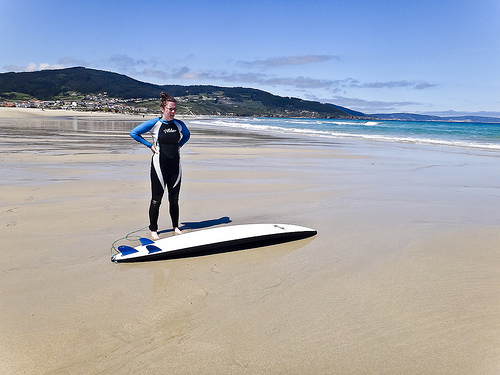Please provide a short description for this region: [0.24, 0.3, 0.41, 0.59]. This segment of the image focuses on a woman dressed in a sporty wetsuit that blends colors of white, black, and vibrant blue, preparing for or having just enjoyed a session of surfing. 